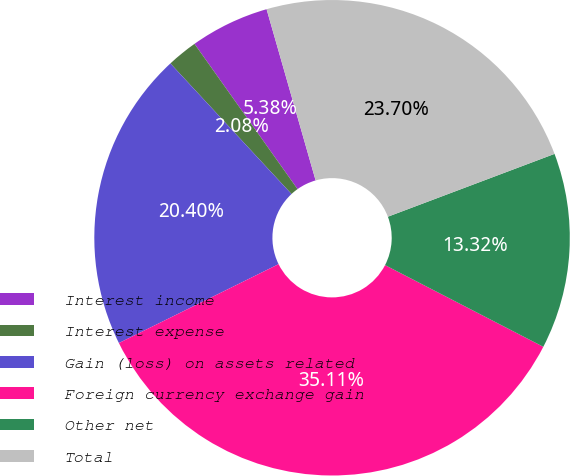<chart> <loc_0><loc_0><loc_500><loc_500><pie_chart><fcel>Interest income<fcel>Interest expense<fcel>Gain (loss) on assets related<fcel>Foreign currency exchange gain<fcel>Other net<fcel>Total<nl><fcel>5.38%<fcel>2.08%<fcel>20.4%<fcel>35.11%<fcel>13.32%<fcel>23.7%<nl></chart> 